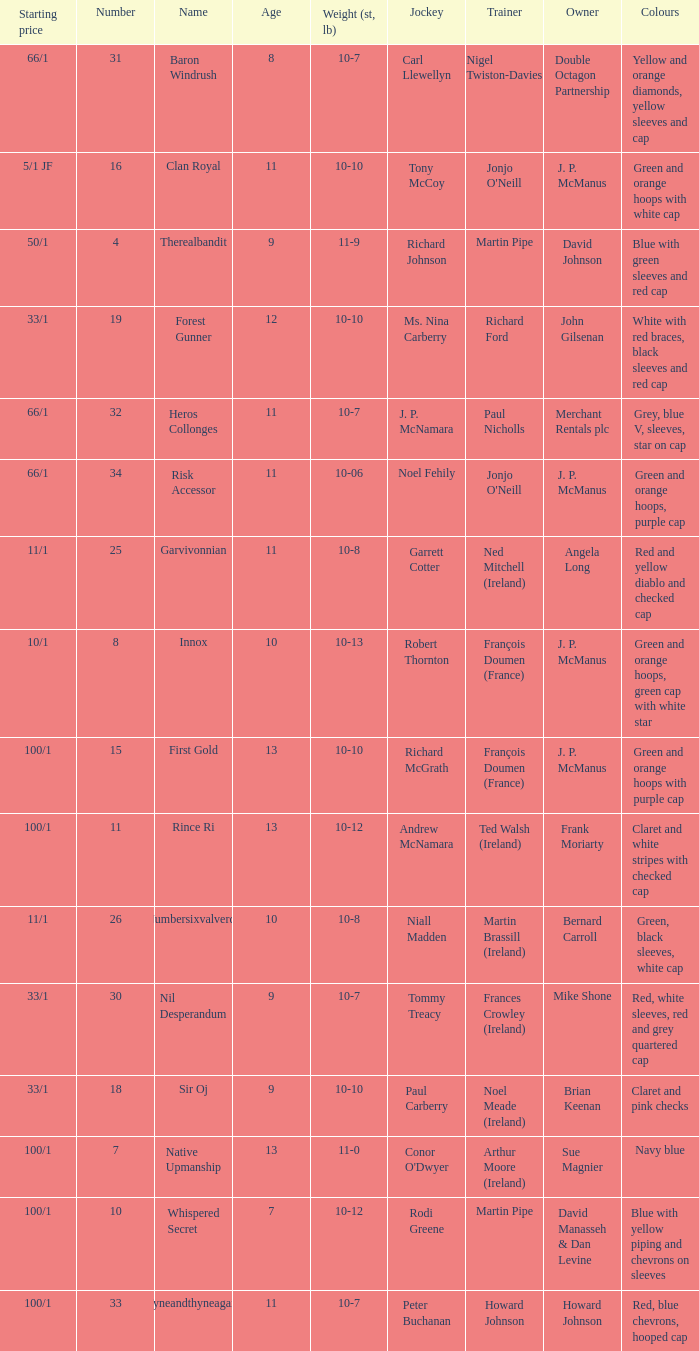What was the name that had a starting price of 11/1 and a jockey named Garrett Cotter? Garvivonnian. 